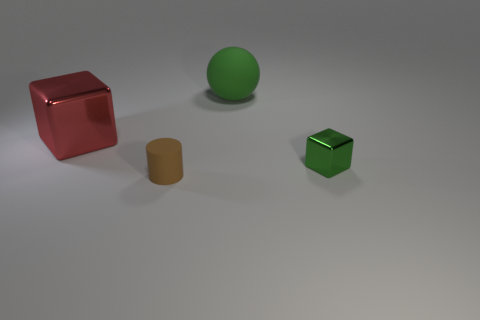What number of other objects are the same size as the rubber cylinder?
Your answer should be very brief. 1. What is the color of the tiny matte object?
Offer a very short reply. Brown. There is a big thing that is to the right of the brown matte cylinder; is it the same color as the matte object in front of the large red shiny thing?
Your answer should be very brief. No. What size is the ball?
Ensure brevity in your answer.  Large. How big is the shiny object that is to the left of the green metallic cube?
Your answer should be compact. Large. The object that is both right of the brown cylinder and in front of the green rubber ball has what shape?
Give a very brief answer. Cube. How many other things are there of the same shape as the red thing?
Your answer should be very brief. 1. What is the color of the sphere that is the same size as the red metal block?
Offer a very short reply. Green. What number of things are gray metallic blocks or small cubes?
Provide a short and direct response. 1. Are there any large cubes to the right of the big matte object?
Provide a short and direct response. No. 